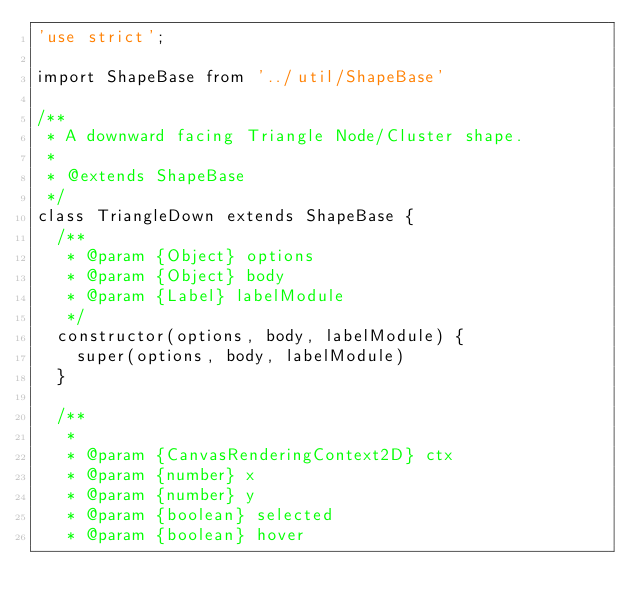<code> <loc_0><loc_0><loc_500><loc_500><_JavaScript_>'use strict';

import ShapeBase from '../util/ShapeBase'

/**
 * A downward facing Triangle Node/Cluster shape.
 *
 * @extends ShapeBase
 */
class TriangleDown extends ShapeBase {
  /**
   * @param {Object} options
   * @param {Object} body
   * @param {Label} labelModule
   */
  constructor(options, body, labelModule) {
    super(options, body, labelModule)
  }

  /**
   *
   * @param {CanvasRenderingContext2D} ctx
   * @param {number} x
   * @param {number} y
   * @param {boolean} selected
   * @param {boolean} hover</code> 